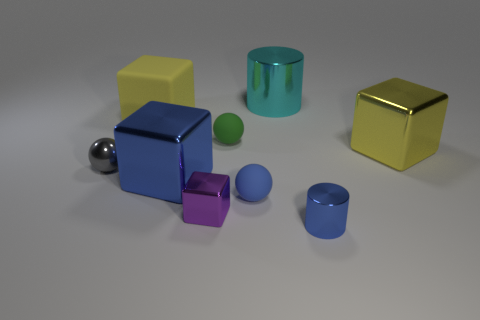Subtract all blue blocks. How many blocks are left? 3 Add 1 tiny green spheres. How many objects exist? 10 Subtract all gray blocks. Subtract all blue cylinders. How many blocks are left? 4 Subtract all cylinders. How many objects are left? 7 Add 8 tiny green matte objects. How many tiny green matte objects are left? 9 Add 7 cyan cylinders. How many cyan cylinders exist? 8 Subtract 0 purple cylinders. How many objects are left? 9 Subtract all metal spheres. Subtract all tiny blocks. How many objects are left? 7 